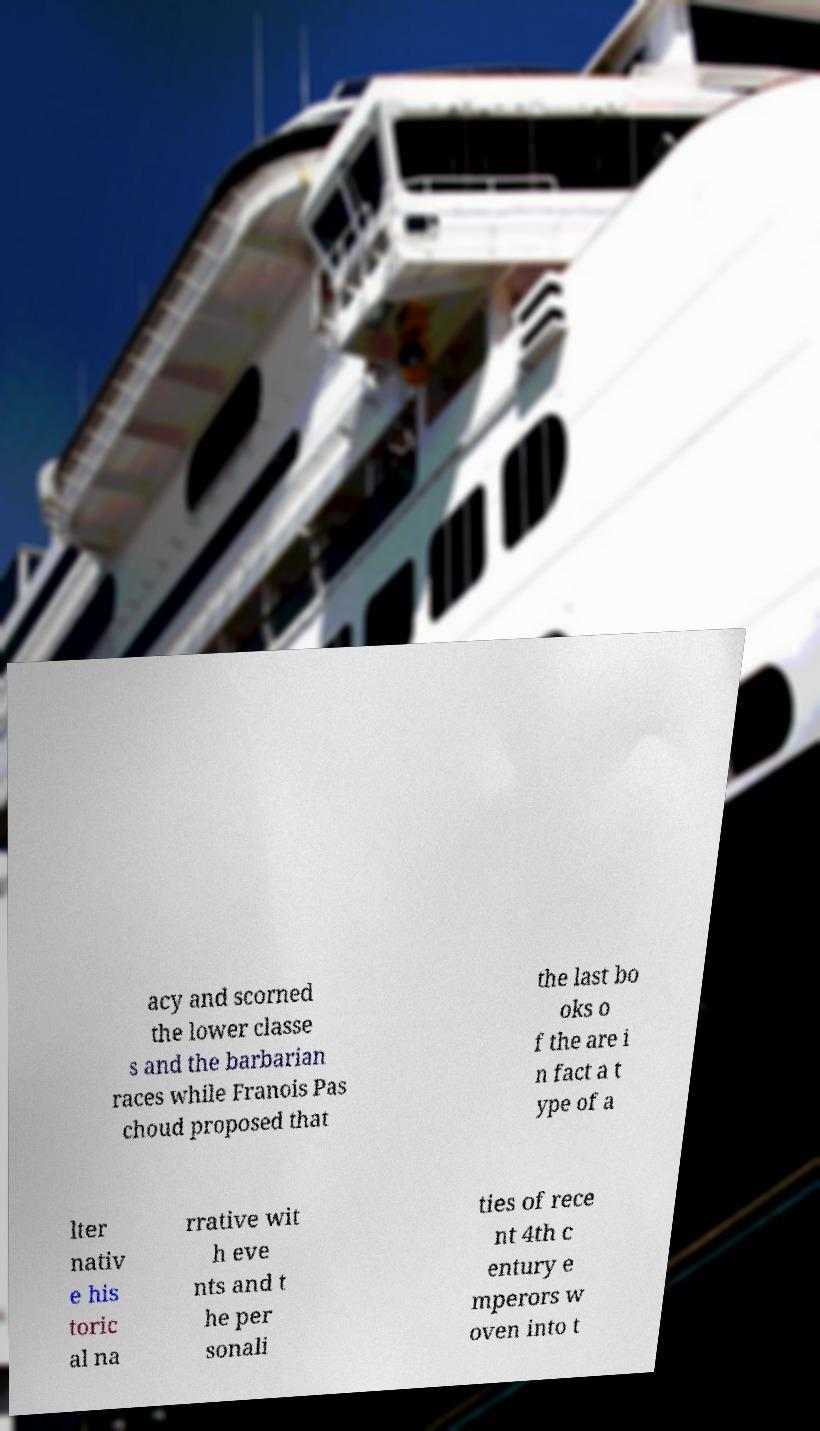Could you assist in decoding the text presented in this image and type it out clearly? acy and scorned the lower classe s and the barbarian races while Franois Pas choud proposed that the last bo oks o f the are i n fact a t ype of a lter nativ e his toric al na rrative wit h eve nts and t he per sonali ties of rece nt 4th c entury e mperors w oven into t 